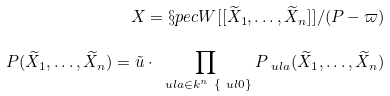<formula> <loc_0><loc_0><loc_500><loc_500>X = \S p e c W [ [ \widetilde { X } _ { 1 } , \dots , \widetilde { X } _ { n } ] ] / ( P - \varpi ) \\ P ( \widetilde { X } _ { 1 } , \dots , \widetilde { X } _ { n } ) = \tilde { u } \cdot \, \prod _ { \ u l { a } \in k ^ { n } \ \{ \ u l { 0 } \} } P _ { \ u l { a } } ( \widetilde { X } _ { 1 } , \dots , \widetilde { X } _ { n } )</formula> 